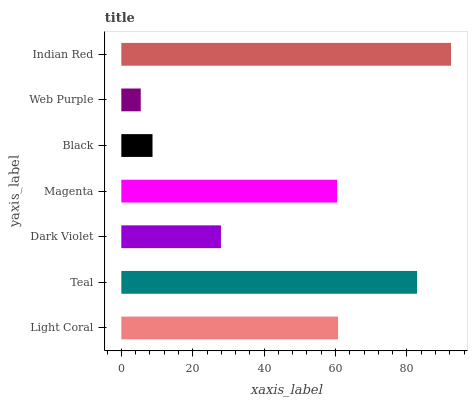Is Web Purple the minimum?
Answer yes or no. Yes. Is Indian Red the maximum?
Answer yes or no. Yes. Is Teal the minimum?
Answer yes or no. No. Is Teal the maximum?
Answer yes or no. No. Is Teal greater than Light Coral?
Answer yes or no. Yes. Is Light Coral less than Teal?
Answer yes or no. Yes. Is Light Coral greater than Teal?
Answer yes or no. No. Is Teal less than Light Coral?
Answer yes or no. No. Is Magenta the high median?
Answer yes or no. Yes. Is Magenta the low median?
Answer yes or no. Yes. Is Teal the high median?
Answer yes or no. No. Is Black the low median?
Answer yes or no. No. 